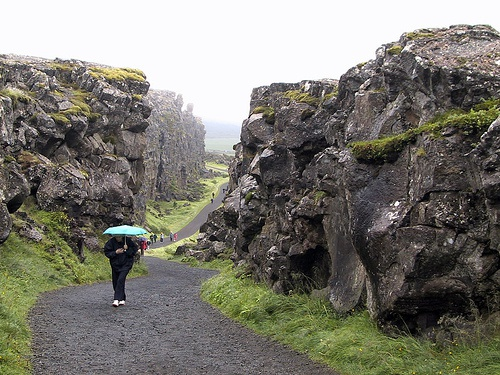Describe the objects in this image and their specific colors. I can see people in white, black, gray, and darkgray tones, umbrella in white, cyan, lightblue, black, and gray tones, people in white, black, maroon, gray, and brown tones, people in white, black, gray, and darkgray tones, and people in white, gray, and black tones in this image. 